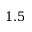<formula> <loc_0><loc_0><loc_500><loc_500>1 . 5</formula> 